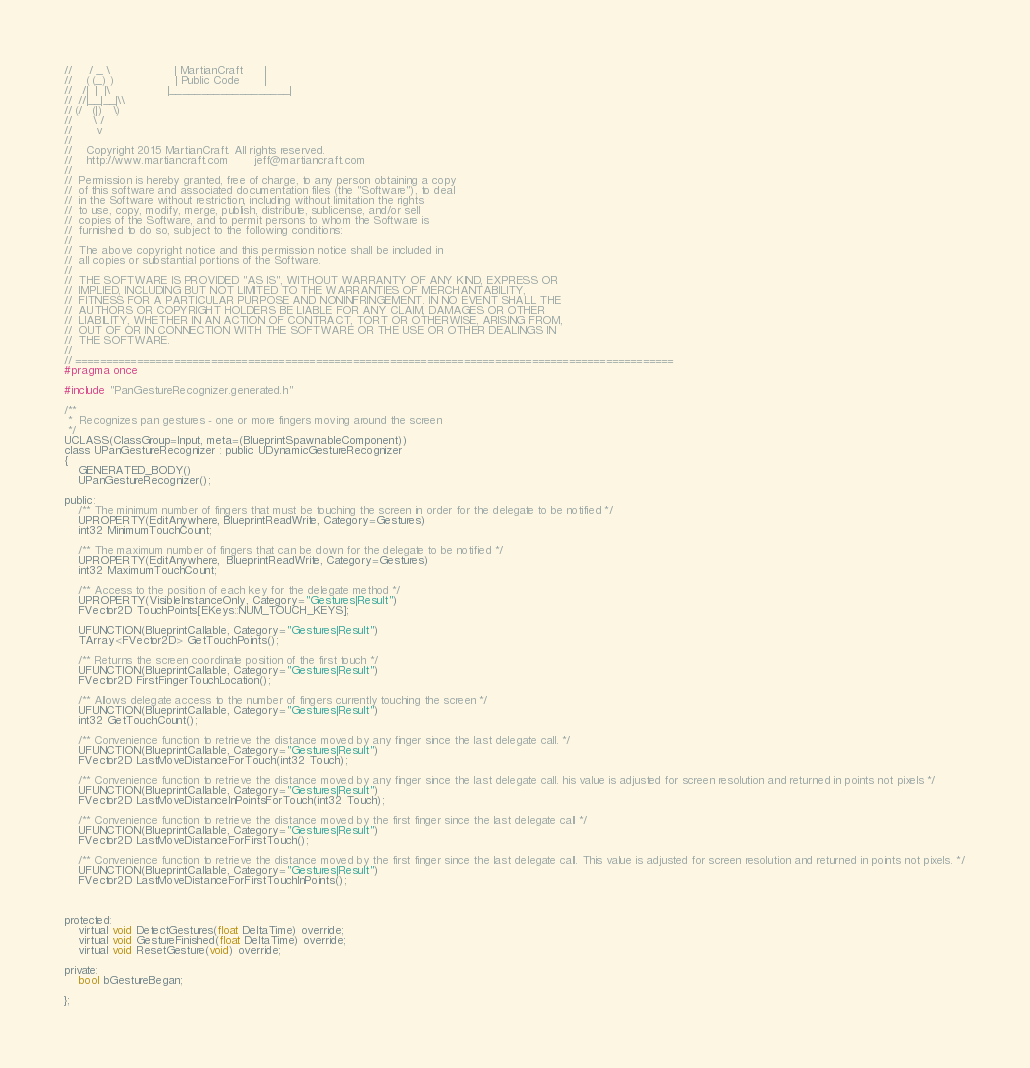<code> <loc_0><loc_0><loc_500><loc_500><_C_>//     / _ \                  | MartianCraft      |
//    ( (_) )                 | Public Code       |
//   /|  |  |\                |___________________|
//  //|__|__|\\
// (/   (|)   \)
//      \ /
//       v
//
//    Copyright 2015 MartianCraft. All rights reserved.
//    http://www.martiancraft.com       jeff@martiancraft.com
//
//	Permission is hereby granted, free of charge, to any person obtaining a copy
//	of this software and associated documentation files (the "Software"), to deal
//	in the Software without restriction, including without limitation the rights
//	to use, copy, modify, merge, publish, distribute, sublicense, and/or sell
//	copies of the Software, and to permit persons to whom the Software is
//	furnished to do so, subject to the following conditions:
//
//	The above copyright notice and this permission notice shall be included in
//	all copies or substantial portions of the Software.
//
//	THE SOFTWARE IS PROVIDED "AS IS", WITHOUT WARRANTY OF ANY KIND, EXPRESS OR
//	IMPLIED, INCLUDING BUT NOT LIMITED TO THE WARRANTIES OF MERCHANTABILITY,
//	FITNESS FOR A PARTICULAR PURPOSE AND NONINFRINGEMENT. IN NO EVENT SHALL THE
//	AUTHORS OR COPYRIGHT HOLDERS BE LIABLE FOR ANY CLAIM, DAMAGES OR OTHER
//	LIABILITY, WHETHER IN AN ACTION OF CONTRACT, TORT OR OTHERWISE, ARISING FROM,
//	OUT OF OR IN CONNECTION WITH THE SOFTWARE OR THE USE OR OTHER DEALINGS IN
//	THE SOFTWARE.
//
// =================================================================================================
#pragma once

#include "PanGestureRecognizer.generated.h"

/**
 *  Recognizes pan gestures - one or more fingers moving around the screen
 */
UCLASS(ClassGroup=Input, meta=(BlueprintSpawnableComponent))
class UPanGestureRecognizer : public UDynamicGestureRecognizer
{
	GENERATED_BODY()
	UPanGestureRecognizer();
	
public:
	/** The minimum number of fingers that must be touching the screen in order for the delegate to be notified */
	UPROPERTY(EditAnywhere, BlueprintReadWrite, Category=Gestures)
	int32 MinimumTouchCount;
	
	/** The maximum number of fingers that can be down for the delegate to be notified */
	UPROPERTY(EditAnywhere,  BlueprintReadWrite, Category=Gestures)
	int32 MaximumTouchCount;
	
	/** Access to the position of each key for the delegate method */
	UPROPERTY(VisibleInstanceOnly, Category="Gestures|Result")
	FVector2D TouchPoints[EKeys::NUM_TOUCH_KEYS];
	
	UFUNCTION(BlueprintCallable, Category="Gestures|Result")
	TArray<FVector2D> GetTouchPoints();
	
	/** Returns the screen coordinate position of the first touch */
	UFUNCTION(BlueprintCallable, Category="Gestures|Result")
	FVector2D FirstFingerTouchLocation();
	
	/** Allows delegate access to the number of fingers currently touching the screen */
	UFUNCTION(BlueprintCallable, Category="Gestures|Result")
	int32 GetTouchCount();
	
	/** Convenience function to retrieve the distance moved by any finger since the last delegate call. */
	UFUNCTION(BlueprintCallable, Category="Gestures|Result")
	FVector2D LastMoveDistanceForTouch(int32 Touch);
	
	/** Convenience function to retrieve the distance moved by any finger since the last delegate call. his value is adjusted for screen resolution and returned in points not pixels */
	UFUNCTION(BlueprintCallable, Category="Gestures|Result")
	FVector2D LastMoveDistanceInPointsForTouch(int32 Touch);
	
	/** Convenience function to retrieve the distance moved by the first finger since the last delegate call */
	UFUNCTION(BlueprintCallable, Category="Gestures|Result")
	FVector2D LastMoveDistanceForFirstTouch();
	
	/** Convenience function to retrieve the distance moved by the first finger since the last delegate call. This value is adjusted for screen resolution and returned in points not pixels. */
	UFUNCTION(BlueprintCallable, Category="Gestures|Result")
	FVector2D LastMoveDistanceForFirstTouchInPoints();
	
	
	
protected:
	virtual void DetectGestures(float DeltaTime) override;
	virtual void GestureFinished(float DeltaTime) override;
	virtual void ResetGesture(void) override;
	
private:
	bool bGestureBegan;
	
};
</code> 